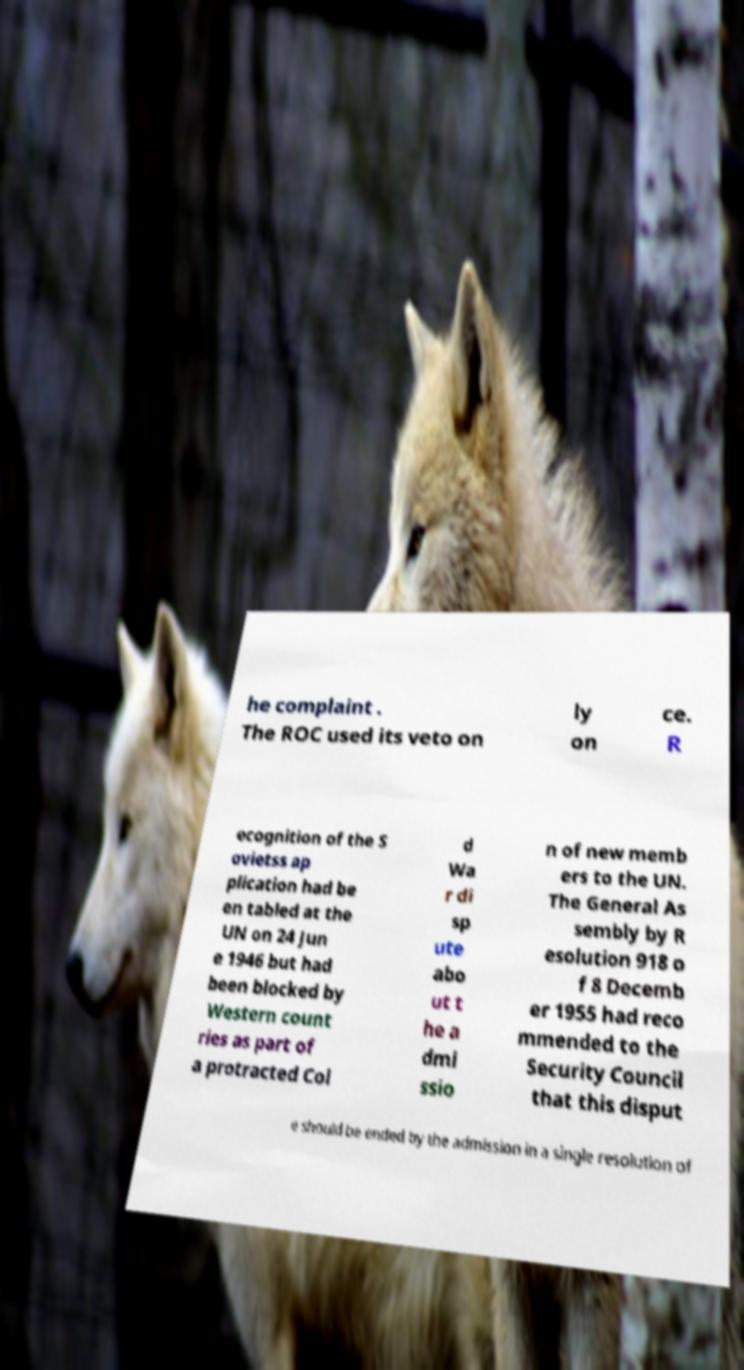Could you assist in decoding the text presented in this image and type it out clearly? he complaint . The ROC used its veto on ly on ce. R ecognition of the S ovietss ap plication had be en tabled at the UN on 24 Jun e 1946 but had been blocked by Western count ries as part of a protracted Col d Wa r di sp ute abo ut t he a dmi ssio n of new memb ers to the UN. The General As sembly by R esolution 918 o f 8 Decemb er 1955 had reco mmended to the Security Council that this disput e should be ended by the admission in a single resolution of 